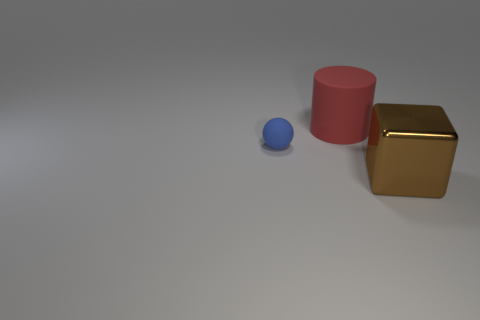The tiny blue matte object has what shape?
Offer a very short reply. Sphere. There is a matte object behind the thing on the left side of the big red matte object; what size is it?
Give a very brief answer. Large. How many things are either purple metallic cubes or blue matte things?
Your response must be concise. 1. Do the red thing and the brown metal thing have the same shape?
Make the answer very short. No. Are there any large cylinders made of the same material as the brown object?
Provide a succinct answer. No. Are there any tiny things behind the big thing that is in front of the big red cylinder?
Give a very brief answer. Yes. Does the thing on the right side of the rubber cylinder have the same size as the big red matte thing?
Your answer should be compact. Yes. How big is the blue ball?
Give a very brief answer. Small. How many small objects are either brown metal things or cyan metal cubes?
Offer a very short reply. 0. What is the size of the thing that is in front of the large red rubber cylinder and on the left side of the brown metallic object?
Your answer should be very brief. Small. 